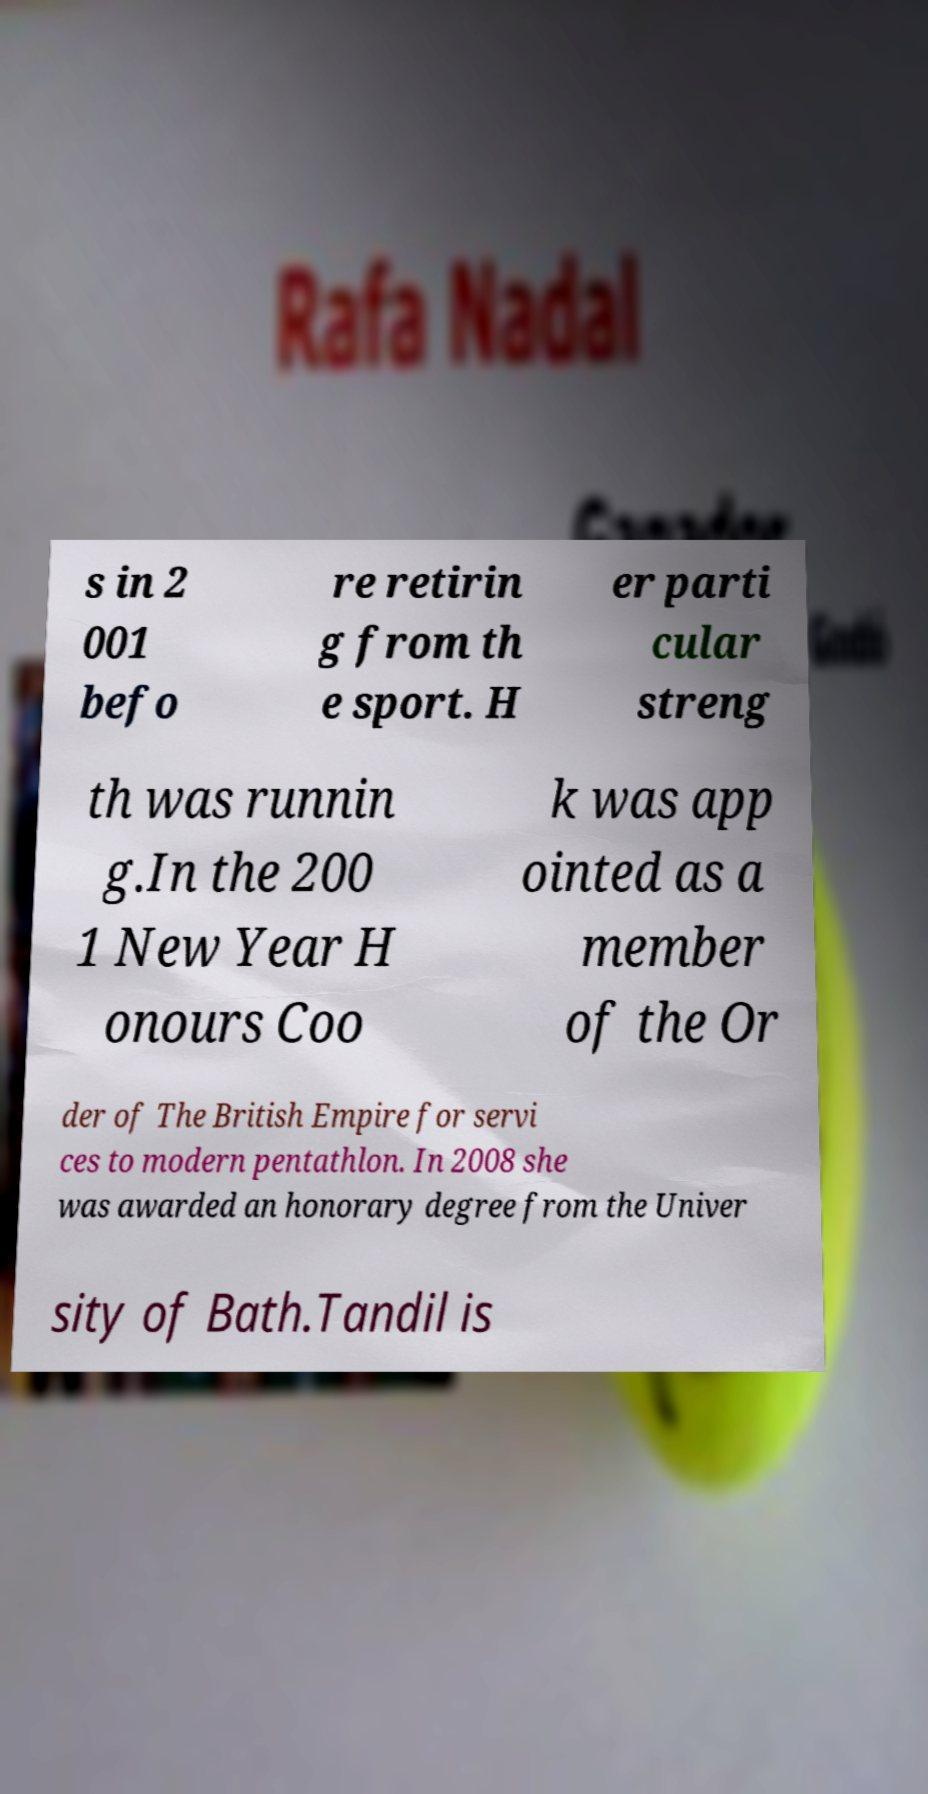Please identify and transcribe the text found in this image. s in 2 001 befo re retirin g from th e sport. H er parti cular streng th was runnin g.In the 200 1 New Year H onours Coo k was app ointed as a member of the Or der of The British Empire for servi ces to modern pentathlon. In 2008 she was awarded an honorary degree from the Univer sity of Bath.Tandil is 